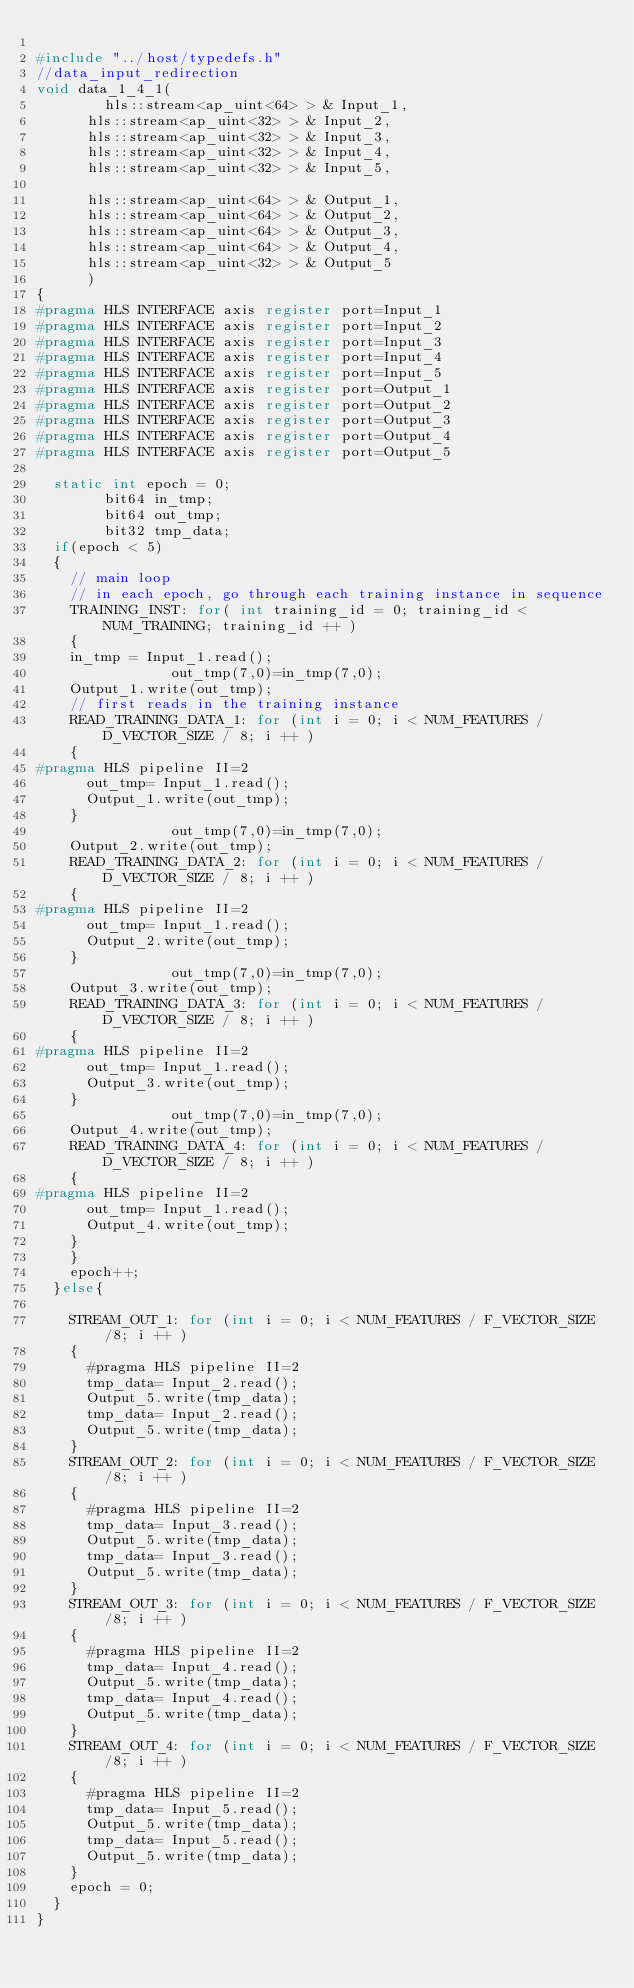<code> <loc_0><loc_0><loc_500><loc_500><_C++_>
#include "../host/typedefs.h"
//data_input_redirection
void data_1_4_1(
		    hls::stream<ap_uint<64> > & Input_1,
			hls::stream<ap_uint<32> > & Input_2,
			hls::stream<ap_uint<32> > & Input_3,
			hls::stream<ap_uint<32> > & Input_4,
			hls::stream<ap_uint<32> > & Input_5,

			hls::stream<ap_uint<64> > & Output_1,
			hls::stream<ap_uint<64> > & Output_2,
			hls::stream<ap_uint<64> > & Output_3,
			hls::stream<ap_uint<64> > & Output_4,
			hls::stream<ap_uint<32> > & Output_5
			)
{
#pragma HLS INTERFACE axis register port=Input_1
#pragma HLS INTERFACE axis register port=Input_2
#pragma HLS INTERFACE axis register port=Input_3
#pragma HLS INTERFACE axis register port=Input_4
#pragma HLS INTERFACE axis register port=Input_5
#pragma HLS INTERFACE axis register port=Output_1
#pragma HLS INTERFACE axis register port=Output_2
#pragma HLS INTERFACE axis register port=Output_3
#pragma HLS INTERFACE axis register port=Output_4
#pragma HLS INTERFACE axis register port=Output_5

	static int epoch = 0;
        bit64 in_tmp;
        bit64 out_tmp;
        bit32 tmp_data;
  if(epoch < 5)
  {
	  // main loop
	  // in each epoch, go through each training instance in sequence
	  TRAINING_INST: for( int training_id = 0; training_id < NUM_TRAINING; training_id ++ )
	  {
		in_tmp = Input_1.read();
                out_tmp(7,0)=in_tmp(7,0);
		Output_1.write(out_tmp);
		// first reads in the training instance
		READ_TRAINING_DATA_1: for (int i = 0; i < NUM_FEATURES / D_VECTOR_SIZE / 8; i ++ )
		{
#pragma HLS pipeline II=2
		  out_tmp= Input_1.read();
		  Output_1.write(out_tmp);
		}
                out_tmp(7,0)=in_tmp(7,0);
		Output_2.write(out_tmp);
		READ_TRAINING_DATA_2: for (int i = 0; i < NUM_FEATURES / D_VECTOR_SIZE / 8; i ++ )
		{
#pragma HLS pipeline II=2
		  out_tmp= Input_1.read();
		  Output_2.write(out_tmp);
		}
                out_tmp(7,0)=in_tmp(7,0);
		Output_3.write(out_tmp);
		READ_TRAINING_DATA_3: for (int i = 0; i < NUM_FEATURES / D_VECTOR_SIZE / 8; i ++ )
		{
#pragma HLS pipeline II=2
		  out_tmp= Input_1.read();
		  Output_3.write(out_tmp);
		}
                out_tmp(7,0)=in_tmp(7,0);
		Output_4.write(out_tmp);
		READ_TRAINING_DATA_4: for (int i = 0; i < NUM_FEATURES / D_VECTOR_SIZE / 8; i ++ )
		{
#pragma HLS pipeline II=2
		  out_tmp= Input_1.read();
		  Output_4.write(out_tmp);
		}
	  }
	  epoch++;
  }else{

	  STREAM_OUT_1: for (int i = 0; i < NUM_FEATURES / F_VECTOR_SIZE /8; i ++ )
	  {
	    #pragma HLS pipeline II=2
		  tmp_data= Input_2.read();
		  Output_5.write(tmp_data);
		  tmp_data= Input_2.read();
		  Output_5.write(tmp_data);
	  }
	  STREAM_OUT_2: for (int i = 0; i < NUM_FEATURES / F_VECTOR_SIZE /8; i ++ )
	  {
	    #pragma HLS pipeline II=2
		  tmp_data= Input_3.read();
		  Output_5.write(tmp_data);
		  tmp_data= Input_3.read();
		  Output_5.write(tmp_data);
	  }
	  STREAM_OUT_3: for (int i = 0; i < NUM_FEATURES / F_VECTOR_SIZE /8; i ++ )
	  {
	    #pragma HLS pipeline II=2
		  tmp_data= Input_4.read();
		  Output_5.write(tmp_data);
		  tmp_data= Input_4.read();
		  Output_5.write(tmp_data);
	  }
	  STREAM_OUT_4: for (int i = 0; i < NUM_FEATURES / F_VECTOR_SIZE /8; i ++ )
	  {
	    #pragma HLS pipeline II=2
		  tmp_data= Input_5.read();
		  Output_5.write(tmp_data);
		  tmp_data= Input_5.read();
		  Output_5.write(tmp_data);
	  }
	  epoch = 0;
  }
}
</code> 